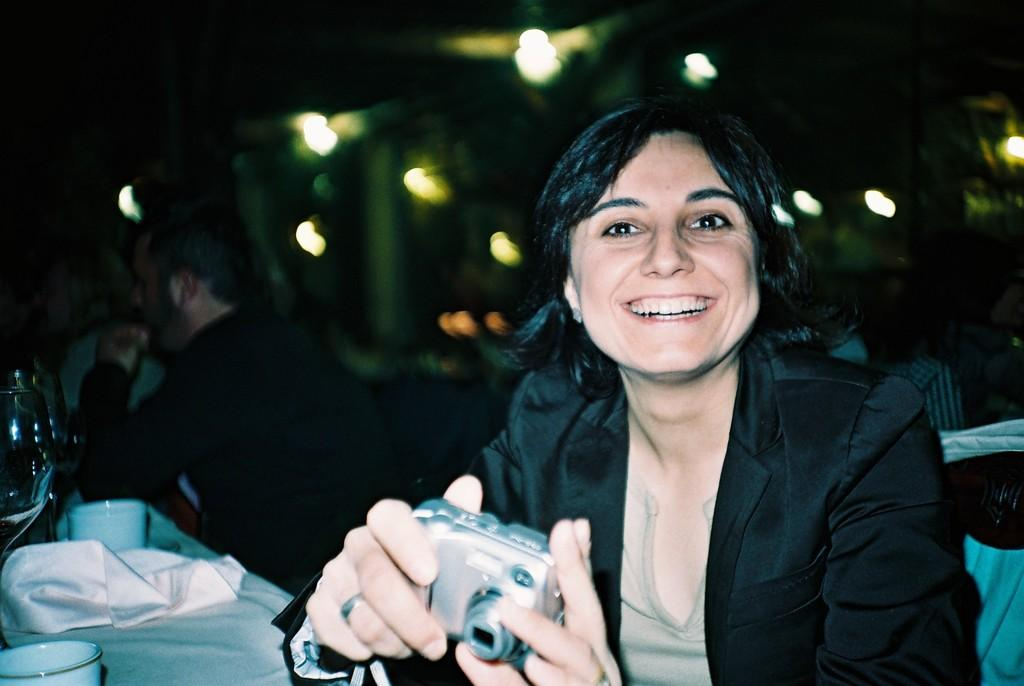How many people are sitting in the image? There are two persons sitting in the image. What is one of the persons holding? One person is holding a camera. What type of material can be seen in the image? There is cloth visible in the image. What object can be used for drinking in the image? There is a cup in the image. What can be seen in the background that might be related to photography? There are focusing lights in the background of the image. What type of train can be seen in the image? There is no train present in the image. How many people are participating in the competition in the image? There is no competition present in the image. 